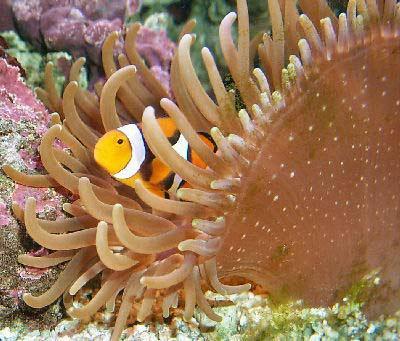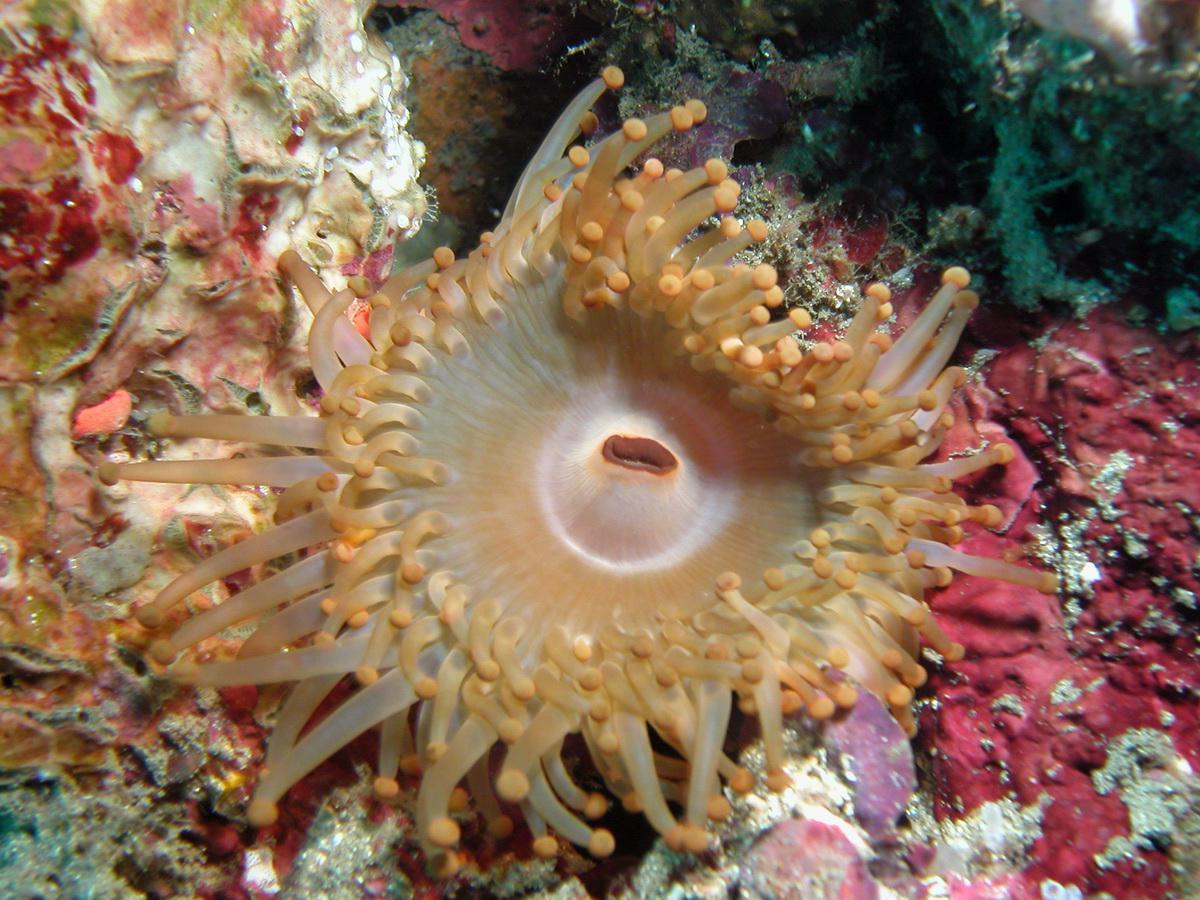The first image is the image on the left, the second image is the image on the right. Evaluate the accuracy of this statement regarding the images: "There is a white anemone in one of the images.". Is it true? Answer yes or no. No. 